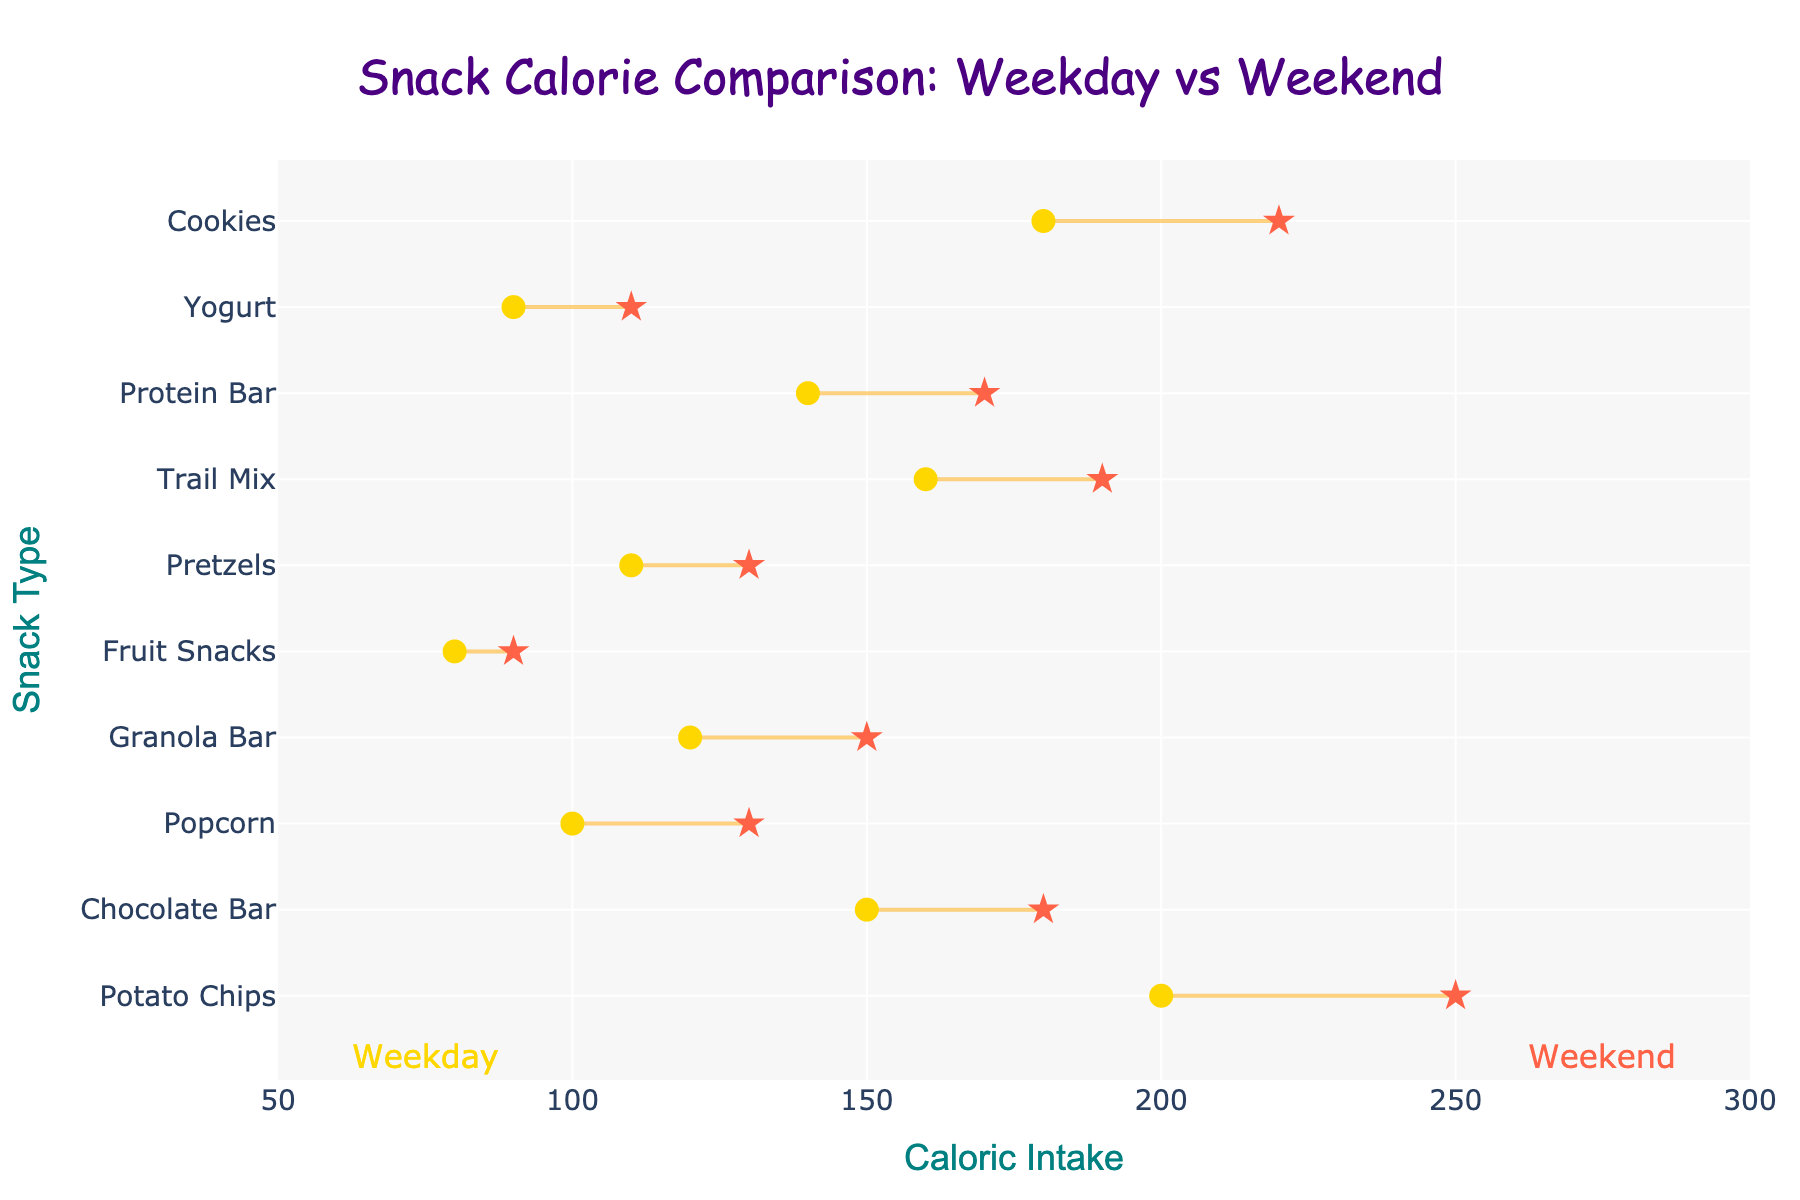What's the title of the plot? The title is displayed at the top center of the plot, usually in a larger font. The title is "Snack Calorie Comparison: Weekday vs Weekend".
Answer: Snack Calorie Comparison: Weekday vs Weekend Which snack has the highest caloric intake on weekdays? By examining the position of markers on the x-axis for weekday caloric intake, Potato Chips have the highest caloric intake at 200 calories.
Answer: Potato Chips Which snack has the smallest difference in caloric intake between weekdays and weekends? The snack with the smallest visual distance between its two markers on the x-axis is Fruit Snacks, with a difference of 90 - 80 = 10 calories.
Answer: Fruit Snacks How many snacks have higher caloric intake on weekends than on weekdays? By noting which markers on the right side (weekend) are higher than the left side (weekday), all snacks (10) have higher caloric intake on weekends than on weekdays.
Answer: 10 What is the caloric intake of Popcorn on weekends? Locate the marker/star symbol for Popcorn on the x-axis corresponding to weekends, which is at 130 calories.
Answer: 130 Which snack shows the largest increase in caloric intake from weekday to weekend? Calculate the difference for each snack, the largest increase is for Cookies (220 - 180 = 40 calories).
Answer: Cookies What's the average weekend caloric intake of all snacks? Sum all weekend caloric intakes and divide by the number of snacks: (250+180+130+150+90+130+190+170+110+220)/10 = 162.
Answer: 162 Identify the two snacks with a Caloric Intake between 100 and 150 during weekdays. We scan the weekday caloric intake markers for values in the range of 100 to 150 which are Popcorn (100) and Granola Bar (120).
Answer: Popcorn, Granola Bar Determine the range of weekday caloric intake values. Identify the minimum (80) and maximum (200) weekday caloric intake values; the range is 200 - 80 = 120 calories.
Answer: 120 Considering only the snacks with over 150 calories on weekdays, how much do their caloric intakes increase on weekends on average? Average weekend increase = ((250-200) + (190-160) + (220-180))/3 = (50 + 30 + 40) / 3 = 40 calories.
Answer: 40 